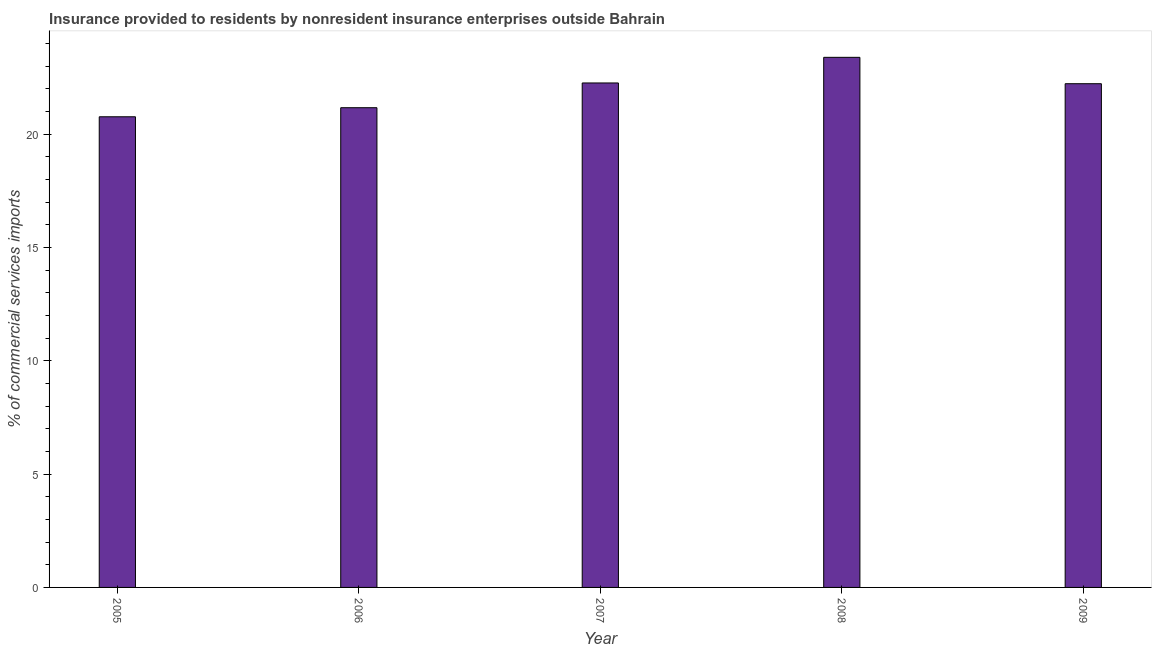Does the graph contain grids?
Your response must be concise. No. What is the title of the graph?
Offer a very short reply. Insurance provided to residents by nonresident insurance enterprises outside Bahrain. What is the label or title of the X-axis?
Offer a very short reply. Year. What is the label or title of the Y-axis?
Provide a short and direct response. % of commercial services imports. What is the insurance provided by non-residents in 2007?
Your answer should be compact. 22.25. Across all years, what is the maximum insurance provided by non-residents?
Keep it short and to the point. 23.39. Across all years, what is the minimum insurance provided by non-residents?
Your answer should be compact. 20.76. In which year was the insurance provided by non-residents maximum?
Offer a terse response. 2008. What is the sum of the insurance provided by non-residents?
Offer a terse response. 109.79. What is the difference between the insurance provided by non-residents in 2005 and 2007?
Make the answer very short. -1.49. What is the average insurance provided by non-residents per year?
Offer a terse response. 21.96. What is the median insurance provided by non-residents?
Offer a very short reply. 22.22. In how many years, is the insurance provided by non-residents greater than 18 %?
Offer a terse response. 5. What is the ratio of the insurance provided by non-residents in 2006 to that in 2008?
Offer a very short reply. 0.91. What is the difference between the highest and the second highest insurance provided by non-residents?
Offer a very short reply. 1.13. What is the difference between the highest and the lowest insurance provided by non-residents?
Keep it short and to the point. 2.62. In how many years, is the insurance provided by non-residents greater than the average insurance provided by non-residents taken over all years?
Provide a short and direct response. 3. How many bars are there?
Your answer should be very brief. 5. Are all the bars in the graph horizontal?
Ensure brevity in your answer.  No. How many years are there in the graph?
Your response must be concise. 5. What is the difference between two consecutive major ticks on the Y-axis?
Your response must be concise. 5. Are the values on the major ticks of Y-axis written in scientific E-notation?
Give a very brief answer. No. What is the % of commercial services imports of 2005?
Give a very brief answer. 20.76. What is the % of commercial services imports in 2006?
Your answer should be compact. 21.16. What is the % of commercial services imports in 2007?
Your answer should be very brief. 22.25. What is the % of commercial services imports of 2008?
Ensure brevity in your answer.  23.39. What is the % of commercial services imports of 2009?
Your response must be concise. 22.22. What is the difference between the % of commercial services imports in 2005 and 2006?
Ensure brevity in your answer.  -0.4. What is the difference between the % of commercial services imports in 2005 and 2007?
Ensure brevity in your answer.  -1.49. What is the difference between the % of commercial services imports in 2005 and 2008?
Offer a terse response. -2.62. What is the difference between the % of commercial services imports in 2005 and 2009?
Your answer should be very brief. -1.46. What is the difference between the % of commercial services imports in 2006 and 2007?
Provide a succinct answer. -1.09. What is the difference between the % of commercial services imports in 2006 and 2008?
Provide a short and direct response. -2.22. What is the difference between the % of commercial services imports in 2006 and 2009?
Give a very brief answer. -1.06. What is the difference between the % of commercial services imports in 2007 and 2008?
Offer a very short reply. -1.13. What is the difference between the % of commercial services imports in 2007 and 2009?
Provide a succinct answer. 0.03. What is the difference between the % of commercial services imports in 2008 and 2009?
Offer a terse response. 1.16. What is the ratio of the % of commercial services imports in 2005 to that in 2007?
Ensure brevity in your answer.  0.93. What is the ratio of the % of commercial services imports in 2005 to that in 2008?
Ensure brevity in your answer.  0.89. What is the ratio of the % of commercial services imports in 2005 to that in 2009?
Your answer should be very brief. 0.93. What is the ratio of the % of commercial services imports in 2006 to that in 2007?
Ensure brevity in your answer.  0.95. What is the ratio of the % of commercial services imports in 2006 to that in 2008?
Your response must be concise. 0.91. What is the ratio of the % of commercial services imports in 2006 to that in 2009?
Offer a very short reply. 0.95. What is the ratio of the % of commercial services imports in 2007 to that in 2009?
Your answer should be very brief. 1. What is the ratio of the % of commercial services imports in 2008 to that in 2009?
Provide a succinct answer. 1.05. 